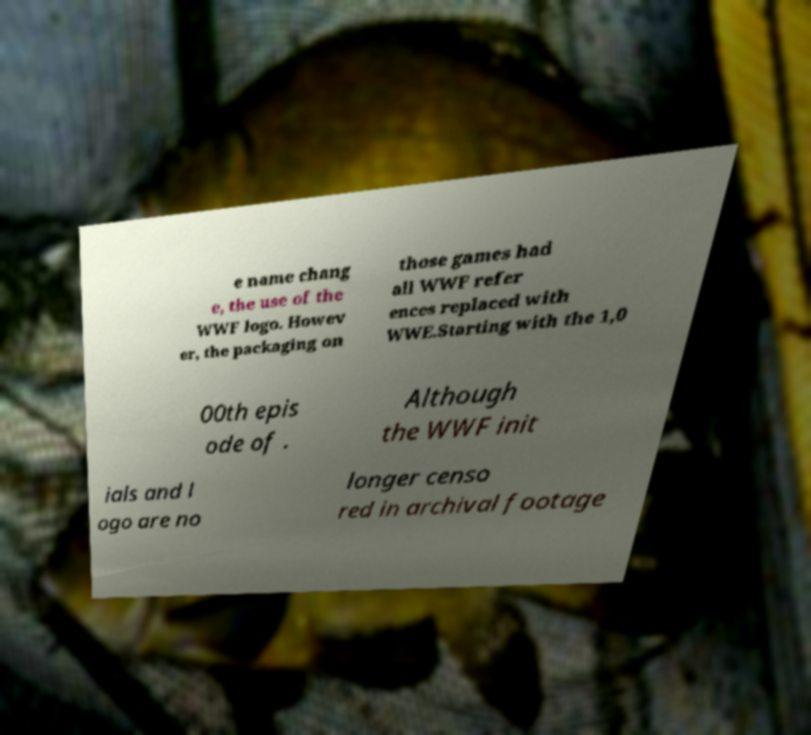There's text embedded in this image that I need extracted. Can you transcribe it verbatim? e name chang e, the use of the WWF logo. Howev er, the packaging on those games had all WWF refer ences replaced with WWE.Starting with the 1,0 00th epis ode of . Although the WWF init ials and l ogo are no longer censo red in archival footage 